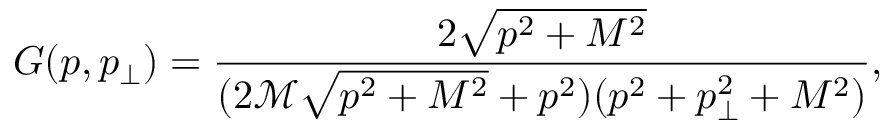<formula> <loc_0><loc_0><loc_500><loc_500>G ( p , p _ { \perp } ) = \frac { 2 \sqrt { p ^ { 2 } + M ^ { 2 } } } { ( 2 \mathcal { M } \sqrt { p ^ { 2 } + M ^ { 2 } } + p ^ { 2 } ) ( p ^ { 2 } + p _ { \perp } ^ { 2 } + M ^ { 2 } ) } ,</formula> 